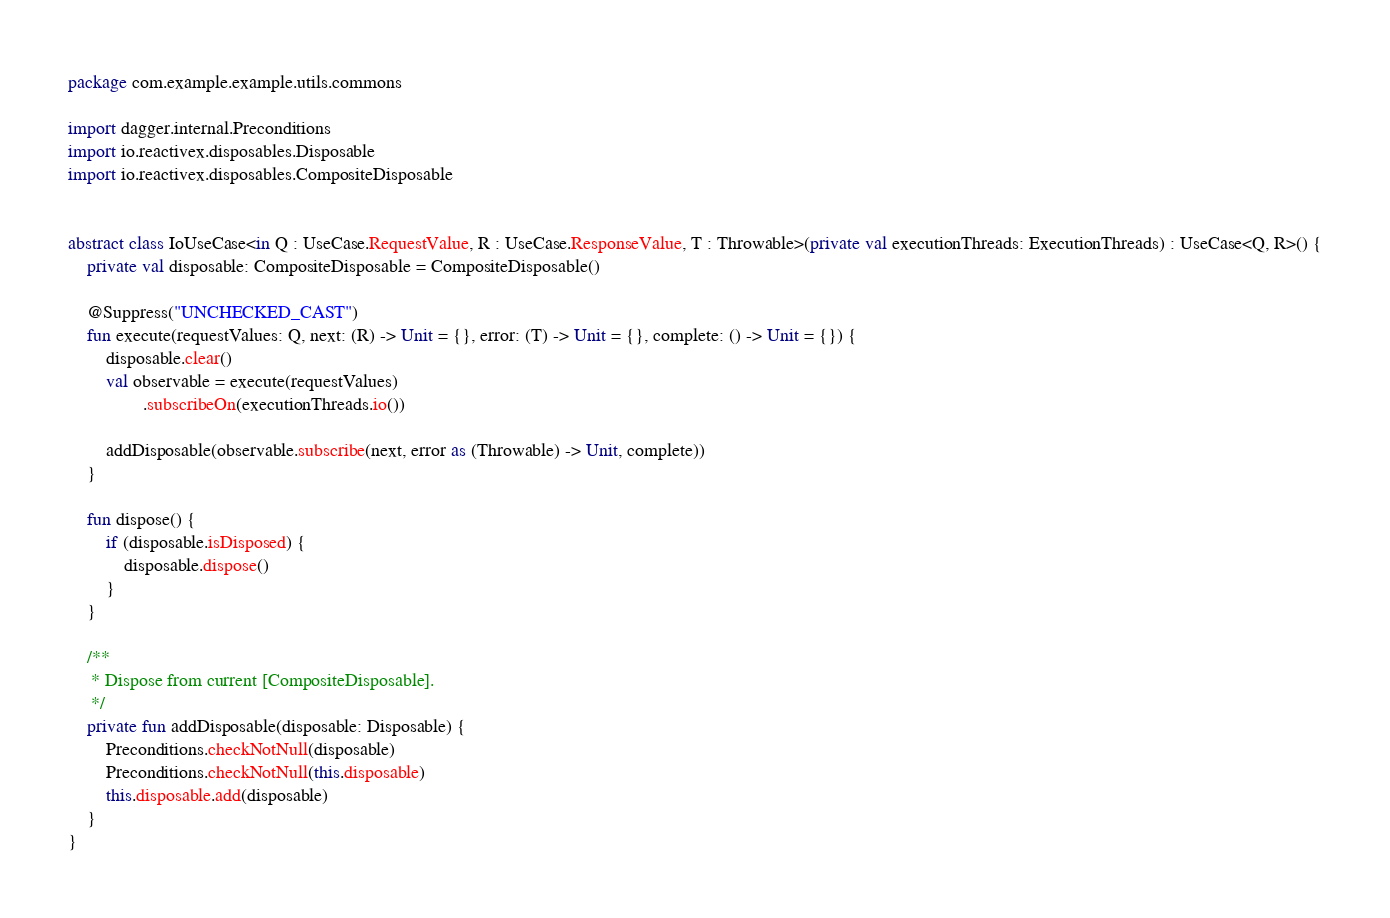<code> <loc_0><loc_0><loc_500><loc_500><_Kotlin_>package com.example.example.utils.commons

import dagger.internal.Preconditions
import io.reactivex.disposables.Disposable
import io.reactivex.disposables.CompositeDisposable


abstract class IoUseCase<in Q : UseCase.RequestValue, R : UseCase.ResponseValue, T : Throwable>(private val executionThreads: ExecutionThreads) : UseCase<Q, R>() {
    private val disposable: CompositeDisposable = CompositeDisposable()

    @Suppress("UNCHECKED_CAST")
    fun execute(requestValues: Q, next: (R) -> Unit = {}, error: (T) -> Unit = {}, complete: () -> Unit = {}) {
        disposable.clear()
        val observable = execute(requestValues)
                .subscribeOn(executionThreads.io())

        addDisposable(observable.subscribe(next, error as (Throwable) -> Unit, complete))
    }

    fun dispose() {
        if (disposable.isDisposed) {
            disposable.dispose()
        }
    }

    /**
     * Dispose from current [CompositeDisposable].
     */
    private fun addDisposable(disposable: Disposable) {
        Preconditions.checkNotNull(disposable)
        Preconditions.checkNotNull(this.disposable)
        this.disposable.add(disposable)
    }
}
</code> 